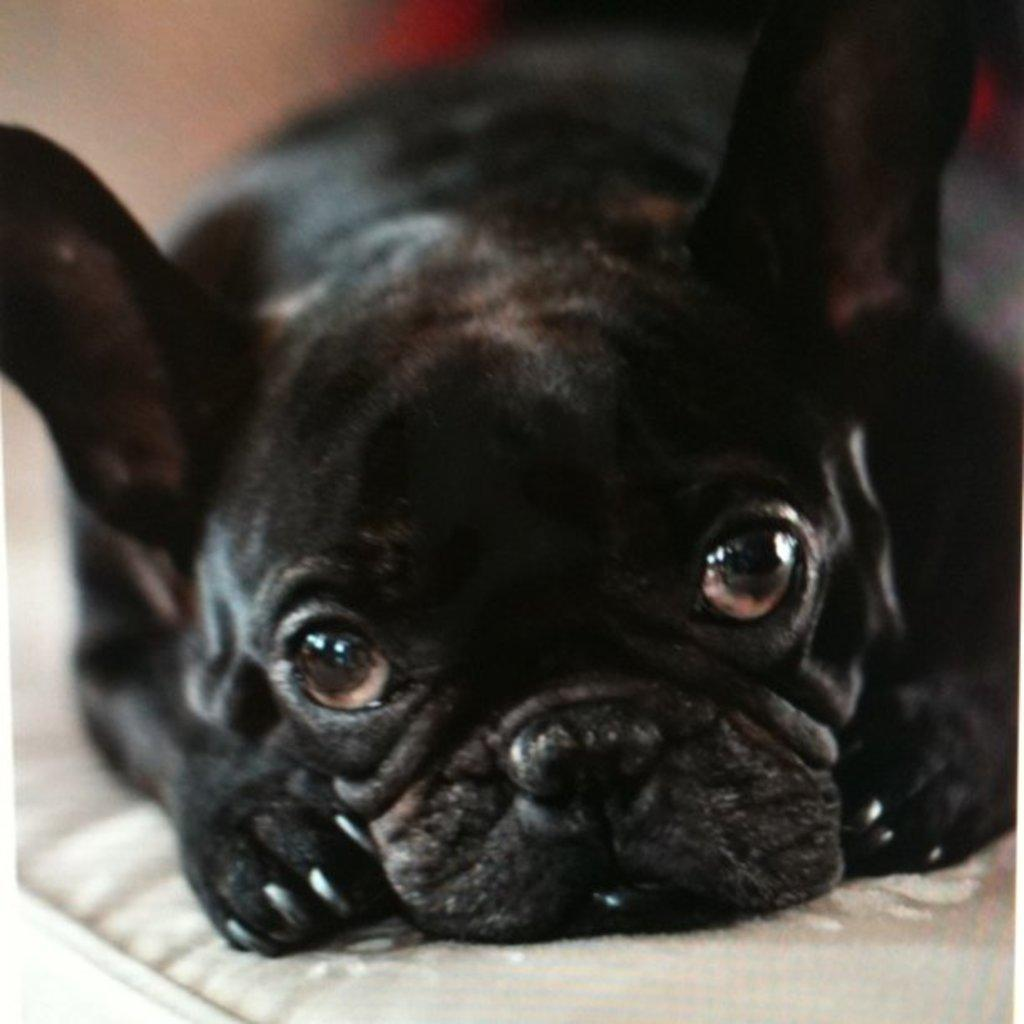What is the main subject of the image? There is a puppy in the image. Where is the puppy located in the image? The puppy is in the center of the image. What color is the puppy? The puppy is black in color. How many dolls are learning to play the piano in the image? There are no dolls or pianos present in the image; it features a black puppy in the center. 